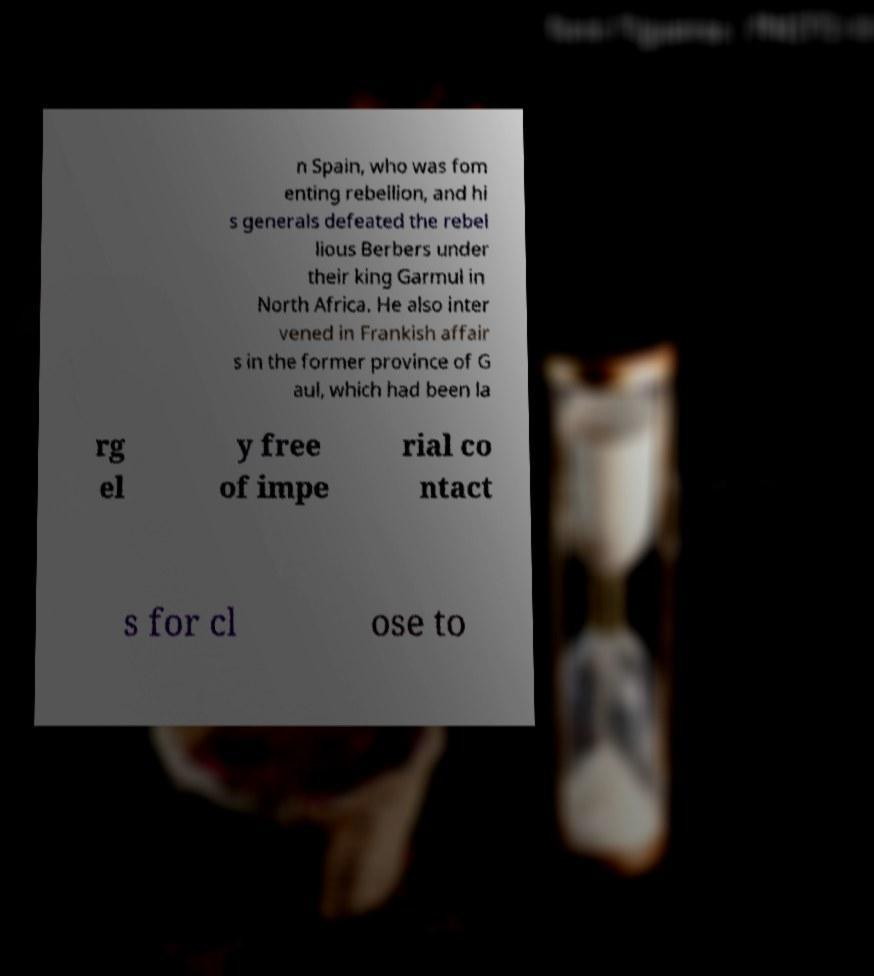Can you read and provide the text displayed in the image?This photo seems to have some interesting text. Can you extract and type it out for me? n Spain, who was fom enting rebellion, and hi s generals defeated the rebel lious Berbers under their king Garmul in North Africa. He also inter vened in Frankish affair s in the former province of G aul, which had been la rg el y free of impe rial co ntact s for cl ose to 